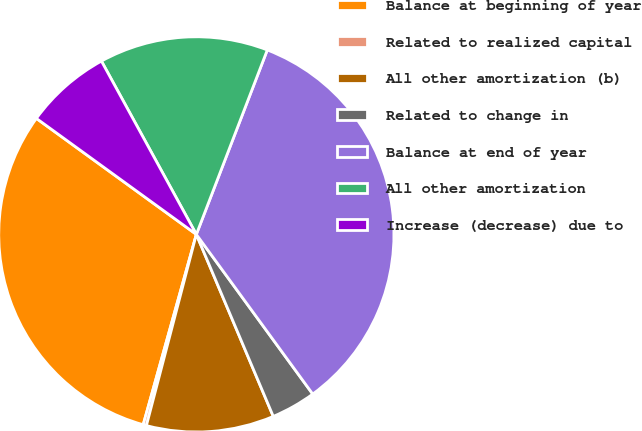Convert chart. <chart><loc_0><loc_0><loc_500><loc_500><pie_chart><fcel>Balance at beginning of year<fcel>Related to realized capital<fcel>All other amortization (b)<fcel>Related to change in<fcel>Balance at end of year<fcel>All other amortization<fcel>Increase (decrease) due to<nl><fcel>30.65%<fcel>0.27%<fcel>10.43%<fcel>3.66%<fcel>34.13%<fcel>13.82%<fcel>7.04%<nl></chart> 